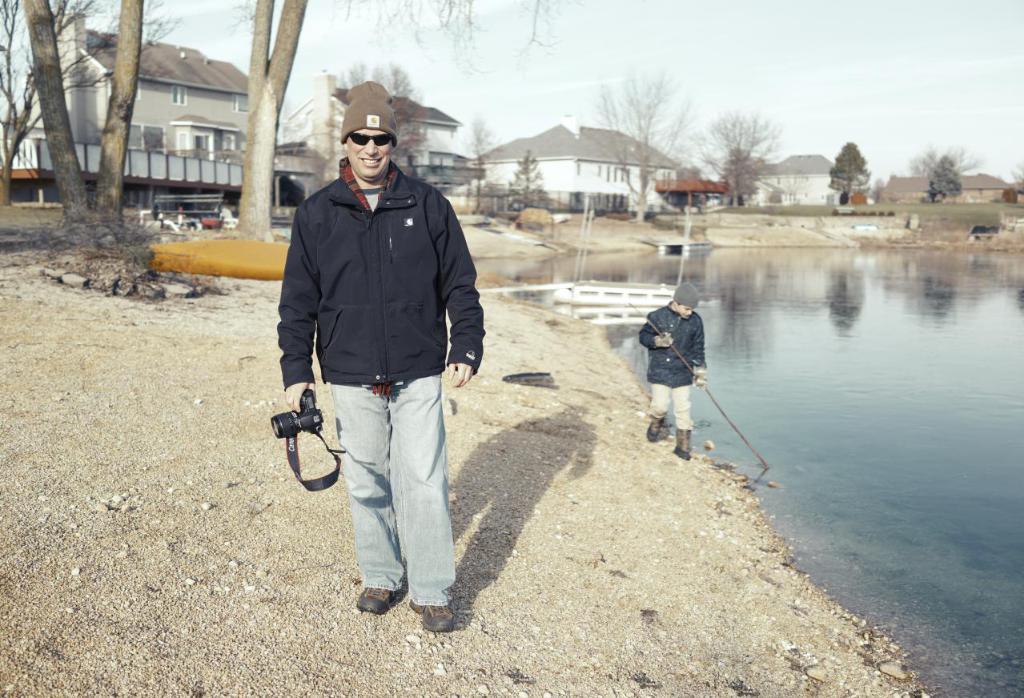Could you give a brief overview of what you see in this image? In this image a man holding camera standing on floor in the foreground and there is another man standing in front of the lake and the lake visible on the right side and in the middle there are trees , houses visible,at the top there is the sky visible. 